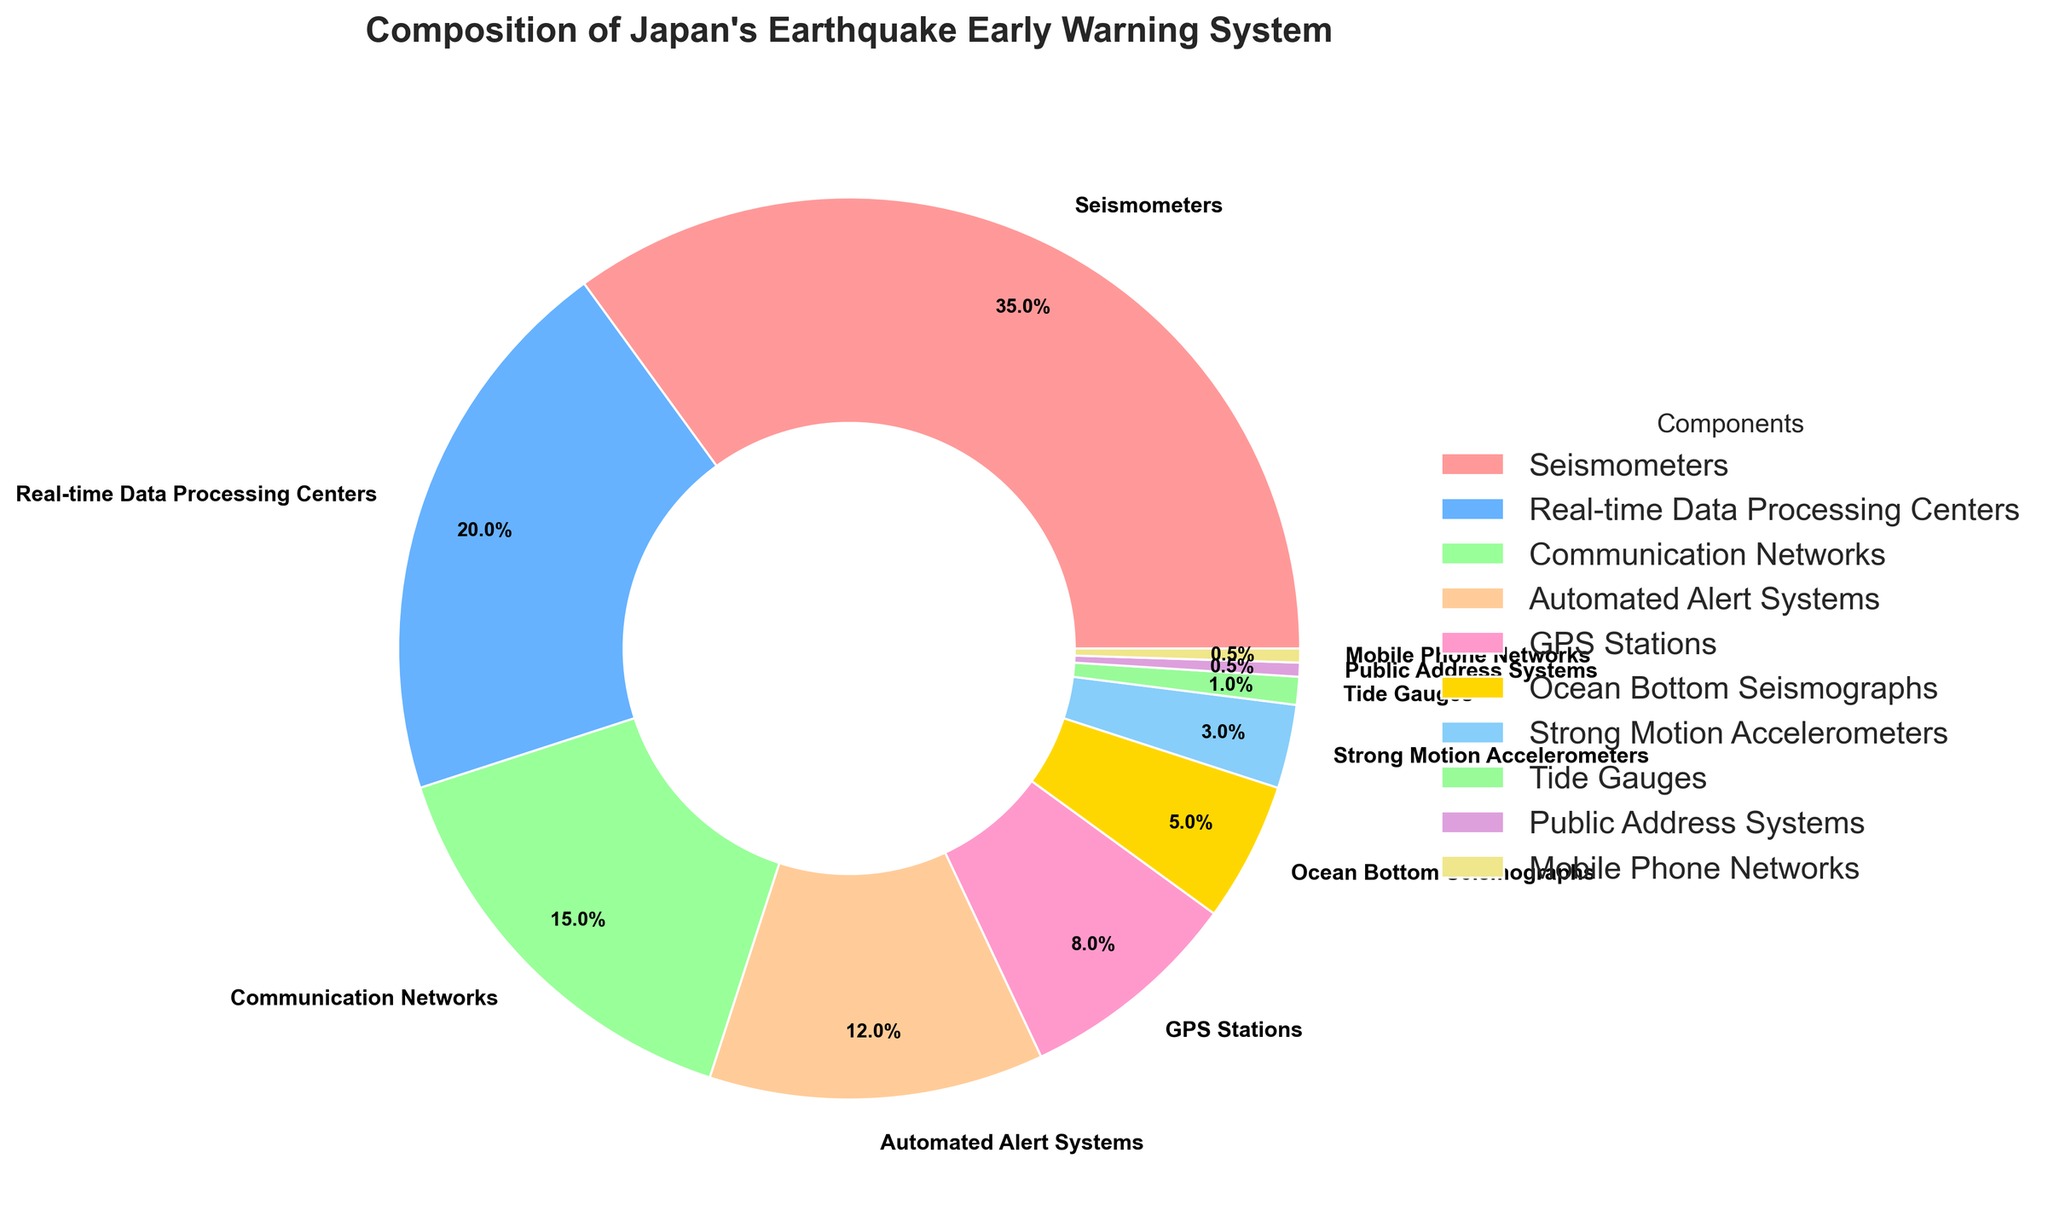What component constitutes the largest share in Japan's earthquake early warning system? The component with the largest percentage slice in the pie chart indicates it has the largest share. According to the chart, Seismometers constitute the largest share at 35%.
Answer: Seismometers Which two components together make up 27% of the system? To find the components that together make up 27%, look for slices in the chart that add up to this value. Automated Alert Systems (12%) and GPS Stations (8%) together add up to 20%. Adding either Tide Gauges (1%) or Public Address Systems and Mobile Phone Networks (both 0.5% each) brings the total to 20%. Including Ocean Bottom Seismographs (5%) gets us to 27%.
Answer: Automated Alert Systems and GPS Stations What is the difference in percentage points between Seismometers and Real-time Data Processing Centers? Subtract the percentage of Real-time Data Processing Centers (20%) from that of Seismometers (35%). The difference in percentage points is 35% - 20% = 15%.
Answer: 15% Which component has a smaller percentage, Communication Networks or GPS Stations? From the pie chart, we can see that Communication Networks take up 15% while GPS Stations take up 8%. Hence, GPS Stations have a smaller percentage than Communication Networks.
Answer: GPS Stations If you combine the percentages of Ocean Bottom Seismographs and Strong Motion Accelerometers, is their combined percentage more or less than that of the Automated Alert Systems? The combined percentage of Ocean Bottom Seismographs (5%) and Strong Motion Accelerometers (3%) is 5% + 3% = 8%. Automated Alert Systems make up 12%, so their combined percentage is less.
Answer: Less Identify the components that individually account for less than 2% of the system. The pie chart shows that Tide Gauges, Public Address Systems, and Mobile Phone Networks each account for 1%, 0.5%, and 0.5%, respectively, thus each of these components account for less than 2%.
Answer: Tide Gauges, Public Address Systems, Mobile Phone Networks What is the total percentage of all components excluding Seismometers and Real-time Data Processing Centers? Sum the percentages of all components except Seismometers (35%) and Real-time Data Processing Centers (20%). The total is 15% + 12% + 8% + 5% + 3% + 1% + 0.5% + 0.5% = 45%.
Answer: 45% Which component is represented by a green color in the pie chart? The green color roughly corresponds to the "99FF99" color code. From the pie chart, it appears that the Strong Motion Accelerometers are represented by this green color.
Answer: Strong Motion Accelerometers By how many percentage points do GPS Stations and Ocean Bottom Seismographs differ? The percentage of GPS Stations is 8% and that of Ocean Bottom Seismographs is 5%. The difference is 8% - 5% = 3 percentage points.
Answer: 3 Is the percentage of Communication Networks closer to that of Automated Alert Systems or to Real-time Data Processing Centers? Compare the differences: (15% - 12%) = 3% for Automated Alert Systems, and (20% - 15%) = 5% for Real-time Data Processing Centers. The difference with Automated Alert Systems is smaller, so it's closer to Automated Alert Systems.
Answer: Automated Alert Systems 